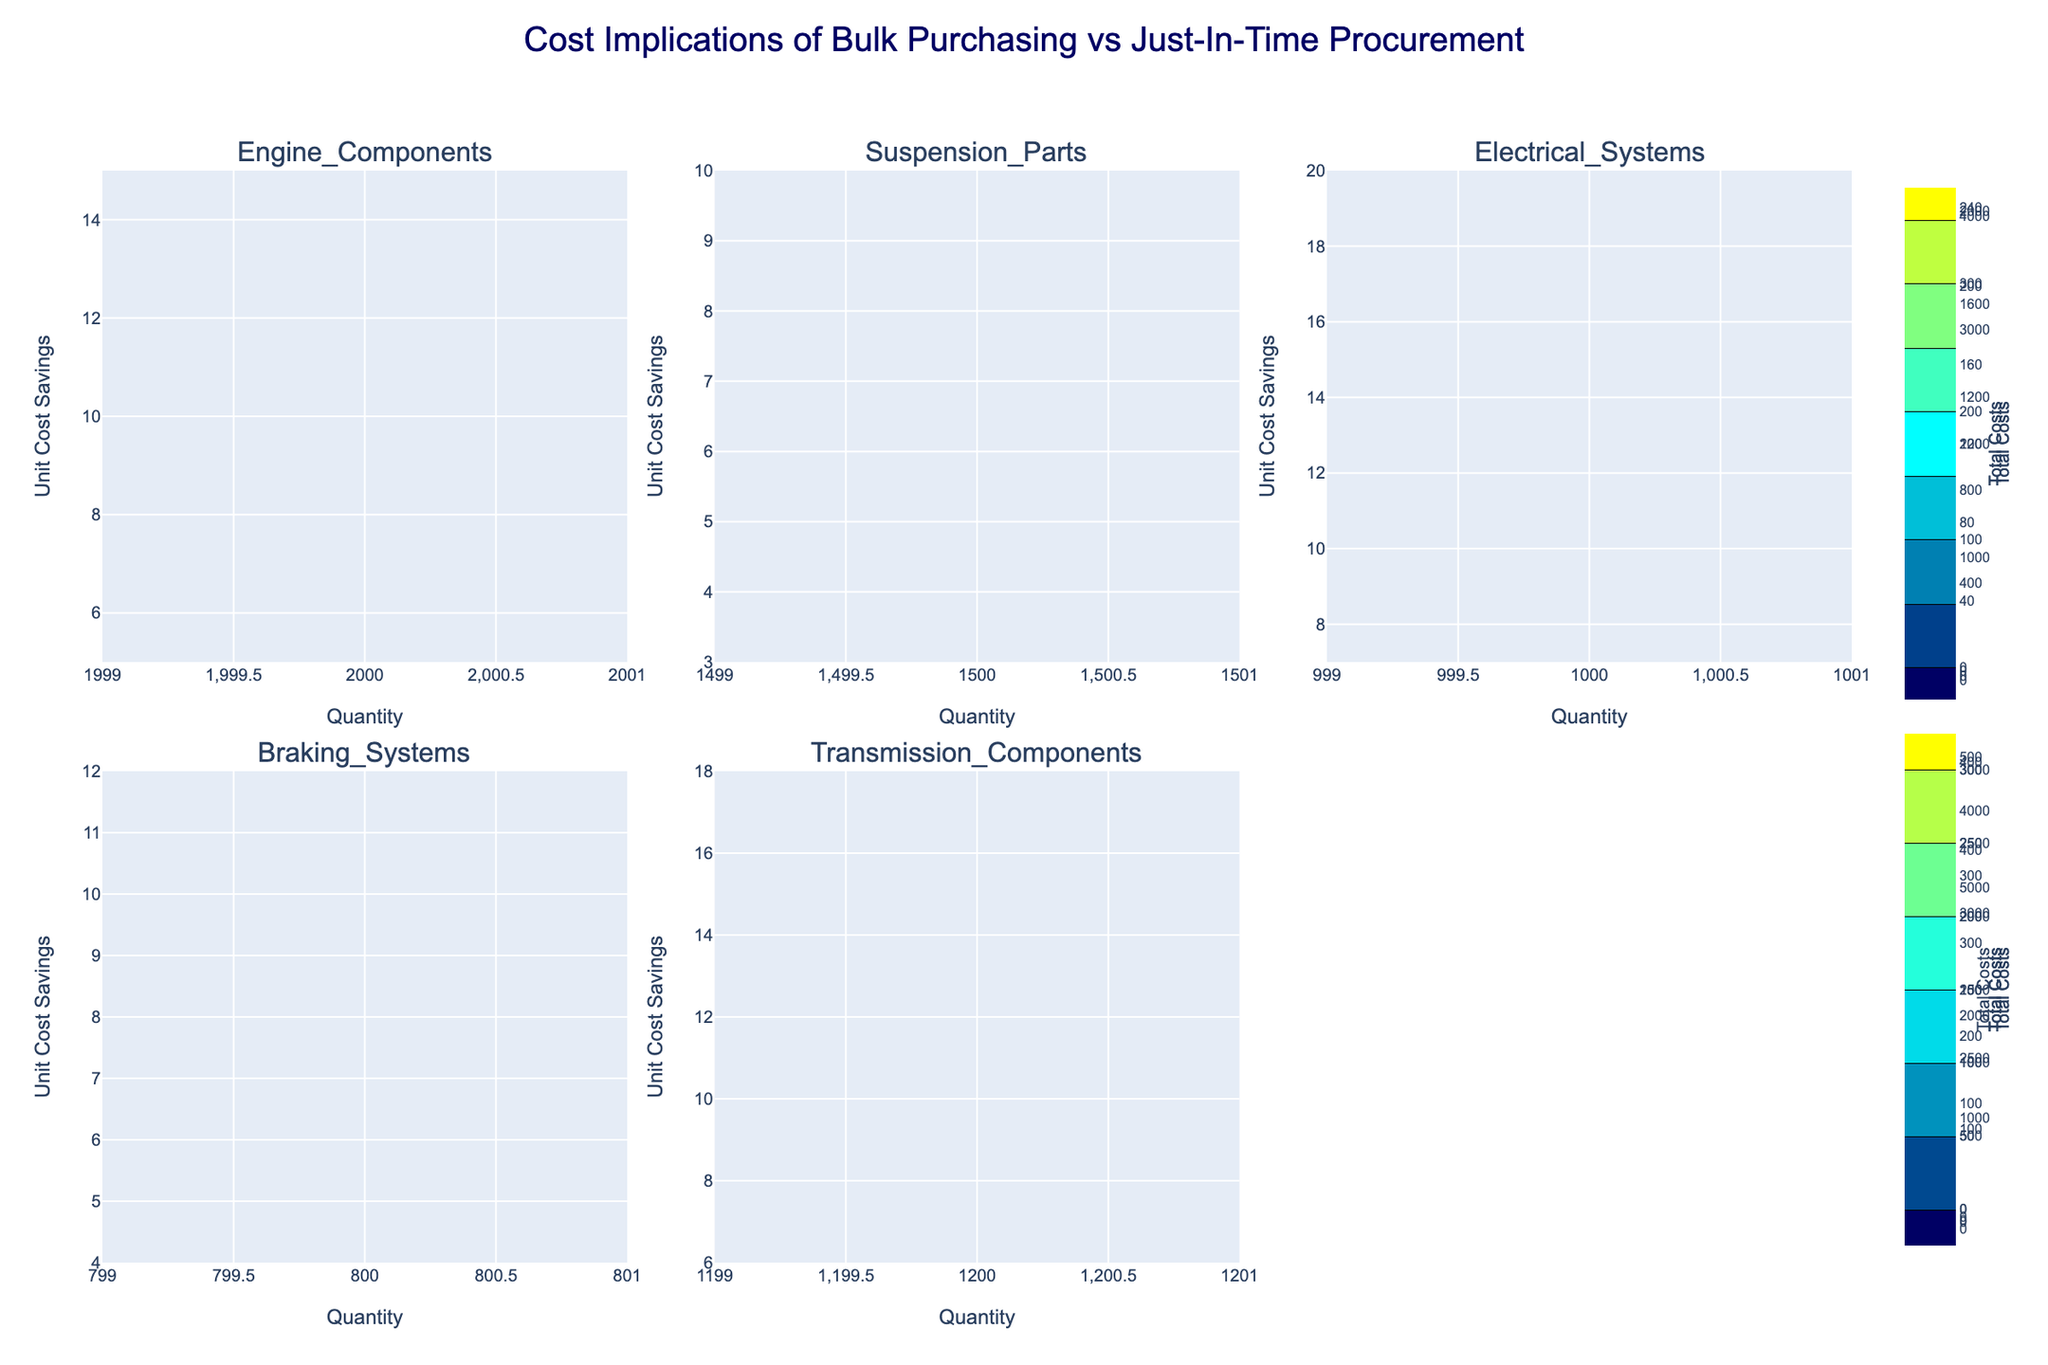what is the highest total cost for the category "Engine Components" in bulk purchasing? Look at the subplot labeled "Engine Components" and find the contour that represents bulk purchasing. Then identify the contour line with the highest value.
Answer: 7000 between bulk purchasing and just-in-time procurement, which method has lower total costs for "Electrical Systems"? Compare the contour lines in the subplot "Electrical Systems" for both procurement methods, and observe which method has contours representing lower values.
Answer: Just-In-Time Procurement For "Braking Systems," what is the range of total costs for just-in-time procurement? Locate the "Braking Systems" subplot, and look at the contour lines for just-in-time procurement. Calculate the difference between the maximum and minimum total costs.
Answer: 250 to 250 How do the storage costs affect the total costs for bulk purchasing across different categories? Observe the subplots and note how the contours change for bulk purchasing. Higher storage costs likely result in higher total costs, visible through higher contours. Compare this effect across all categories.
Answer: Higher storage costs increase total costs What procurement method results in the largest unit cost savings for "Suspension Parts"? In the subplot titled "Suspension Parts," compare the positions of the contours for both procurement methods along the "Unit Cost Savings" axis. Identify which method stretch further.
Answer: Bulk Purchasing Between "Transmission Components" and "Engine Components," which category exhibits a higher variation in total costs for bulk purchasing? Compare the extent of variation in the contour lines of the bulk purchasing method for both "Transmission Components" and "Engine Components" subplots. Assess which subplot has a wider spread of contour values.
Answer: Engine Components In the case of "Electrical Systems," how do the total costs compare between a quantity of 1000 for bulk purchasing and just-in-time procurement? In the "Electrical Systems" subplot, compare the contour line values at the quantity level of 1000 for both procurement methods.
Answer: Bulk purchasing has higher total costs What is the color gradient used to represent total costs in the contours? Examine the color scheme applied to the contour plots. It transitions from dark blue (low costs) to cyan (mid-range costs) to yellow (high costs).
Answer: Dark blue to cyan to yellow Which category shows the smallest difference in total costs between bulk purchasing and just-in-time procurement? Compare the subplots to assess the difference in contour values between both procurement methods for each category, identifying the smallest difference.
Answer: Braking Systems 